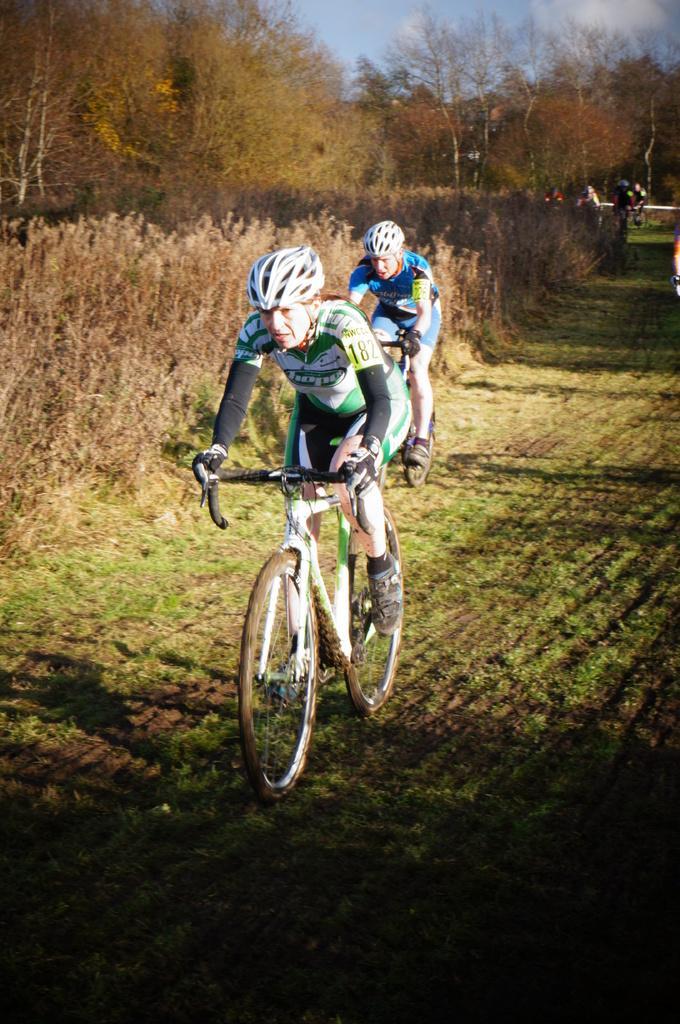How would you summarize this image in a sentence or two? In this image there is the sky, there are clouds in the sky, there are trees, there are trees truncated towards the left of the image, there are persons riding bicycles, there is grass. 